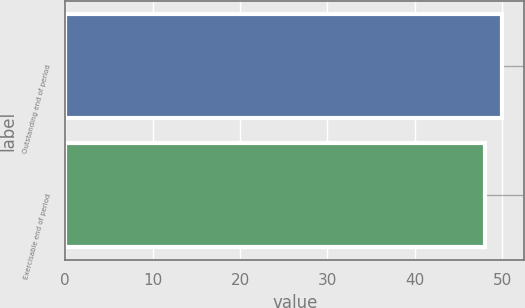<chart> <loc_0><loc_0><loc_500><loc_500><bar_chart><fcel>Outstanding end of period<fcel>Exercisable end of period<nl><fcel>50<fcel>48<nl></chart> 